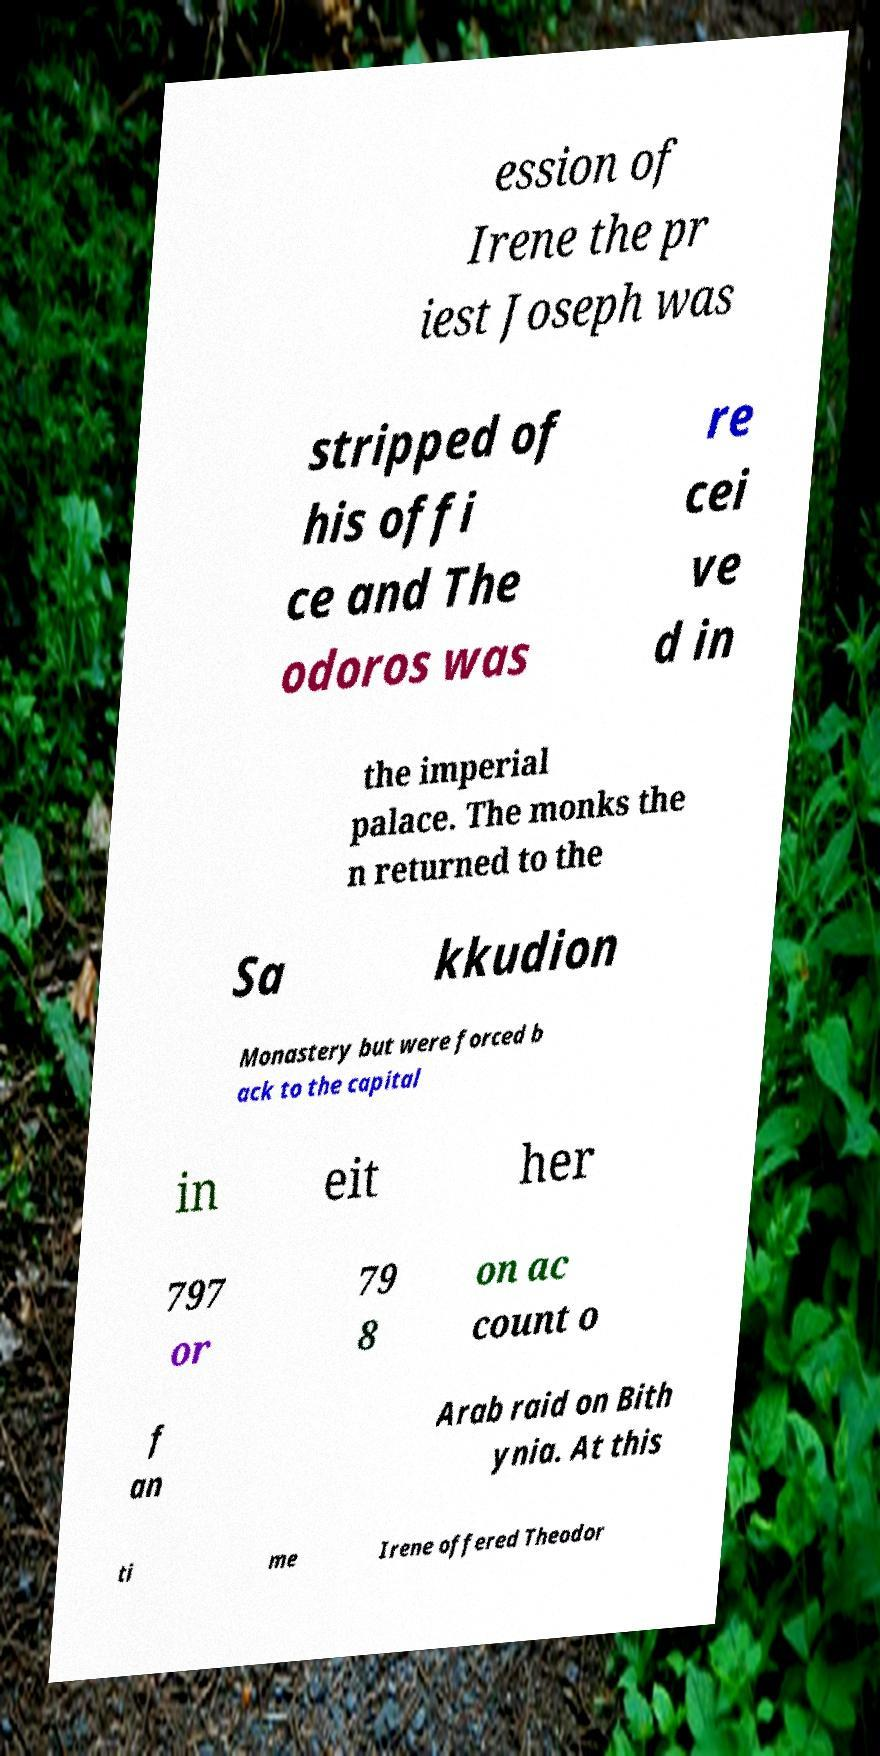Please identify and transcribe the text found in this image. ession of Irene the pr iest Joseph was stripped of his offi ce and The odoros was re cei ve d in the imperial palace. The monks the n returned to the Sa kkudion Monastery but were forced b ack to the capital in eit her 797 or 79 8 on ac count o f an Arab raid on Bith ynia. At this ti me Irene offered Theodor 